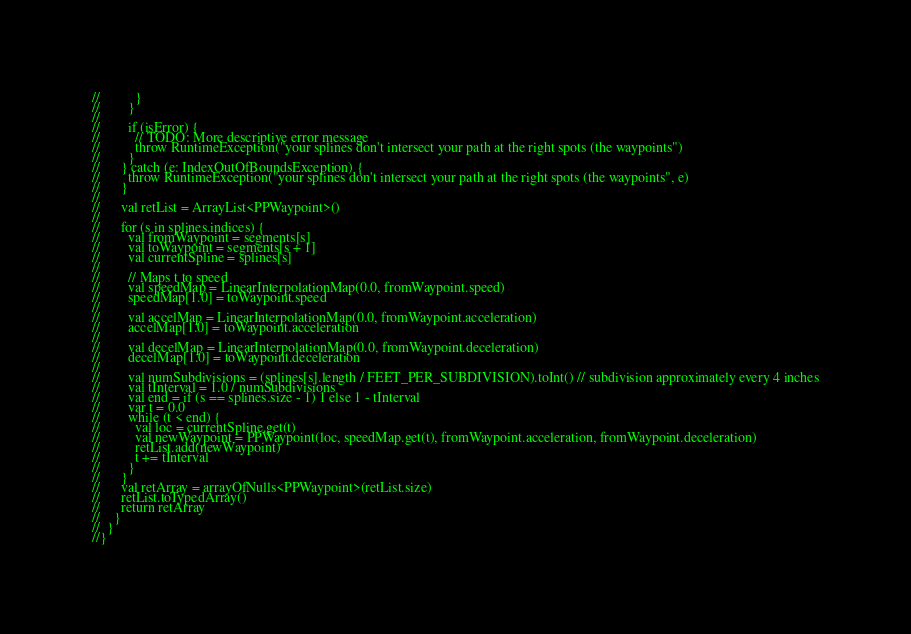<code> <loc_0><loc_0><loc_500><loc_500><_Kotlin_>//          }
//        }
//
//        if (isError) {
//          // TODO: More descriptive error message
//          throw RuntimeException("your splines don't intersect your path at the right spots (the waypoints")
//        }
//      } catch (e: IndexOutOfBoundsException) {
//        throw RuntimeException("your splines don't intersect your path at the right spots (the waypoints", e)
//      }
//
//      val retList = ArrayList<PPWaypoint>()
//
//      for (s in splines.indices) {
//        val fromWaypoint = segments[s]
//        val toWaypoint = segments[s + 1]
//        val currentSpline = splines[s]
//
//        // Maps t to speed
//        val speedMap = LinearInterpolationMap(0.0, fromWaypoint.speed)
//        speedMap[1.0] = toWaypoint.speed
//
//        val accelMap = LinearInterpolationMap(0.0, fromWaypoint.acceleration)
//        accelMap[1.0] = toWaypoint.acceleration
//
//        val decelMap = LinearInterpolationMap(0.0, fromWaypoint.deceleration)
//        decelMap[1.0] = toWaypoint.deceleration
//
//        val numSubdivisions = (splines[s].length / FEET_PER_SUBDIVISION).toInt() // subdivision approximately every 4 inches
//        val tInterval = 1.0 / numSubdivisions
//        val end = if (s == splines.size - 1) 1 else 1 - tInterval
//        var t = 0.0
//        while (t < end) {
//          val loc = currentSpline.get(t)
//          val newWaypoint = PPWaypoint(loc, speedMap.get(t), fromWaypoint.acceleration, fromWaypoint.deceleration)
//          retList.add(newWaypoint)
//          t += tInterval
//        }
//      }
//      val retArray = arrayOfNulls<PPWaypoint>(retList.size)
//      retList.toTypedArray()
//      return retArray
//    }
//  }
//}
</code> 